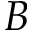<formula> <loc_0><loc_0><loc_500><loc_500>B</formula> 